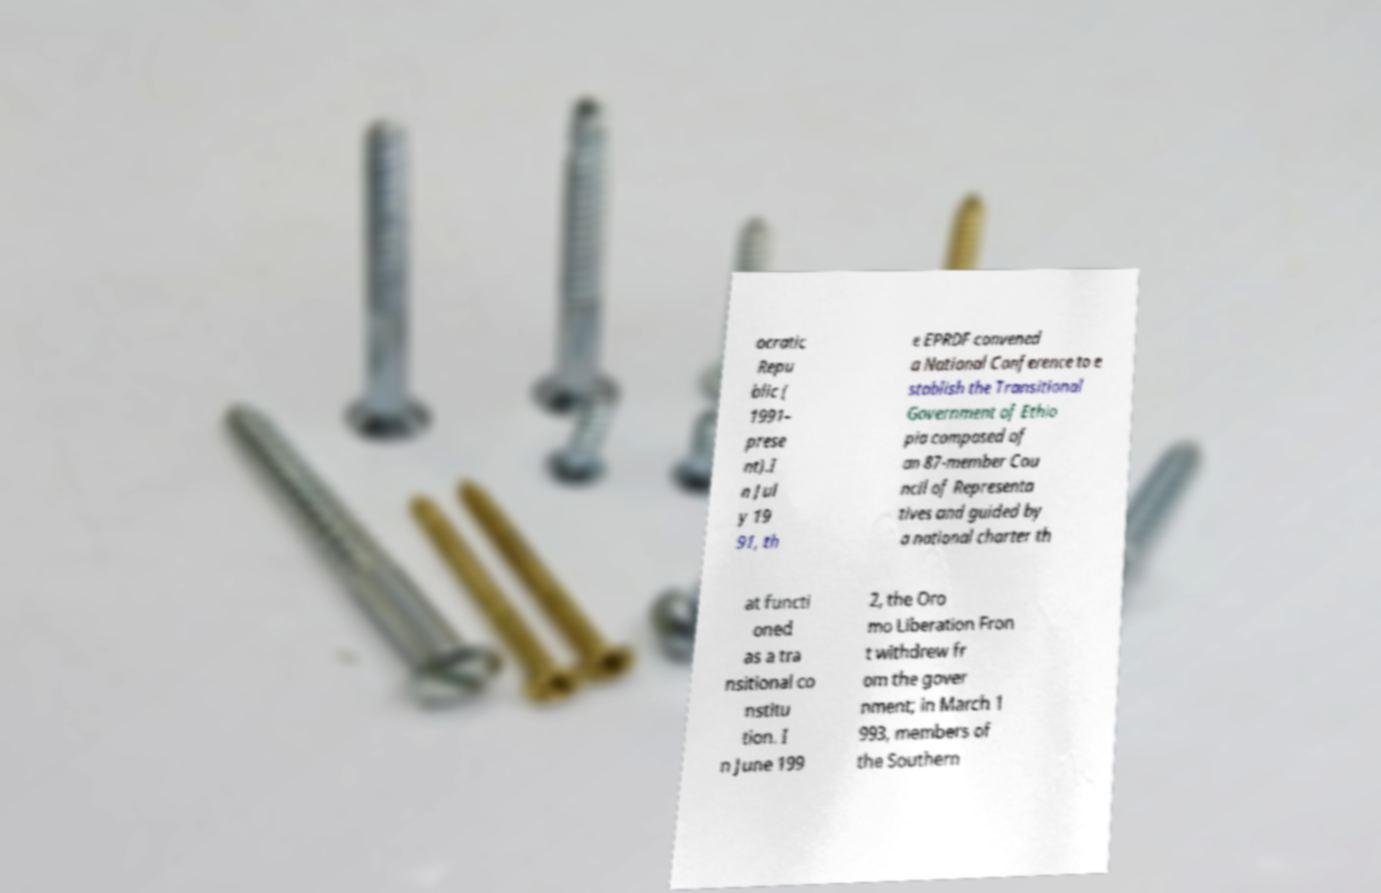Can you accurately transcribe the text from the provided image for me? ocratic Repu blic ( 1991– prese nt).I n Jul y 19 91, th e EPRDF convened a National Conference to e stablish the Transitional Government of Ethio pia composed of an 87-member Cou ncil of Representa tives and guided by a national charter th at functi oned as a tra nsitional co nstitu tion. I n June 199 2, the Oro mo Liberation Fron t withdrew fr om the gover nment; in March 1 993, members of the Southern 